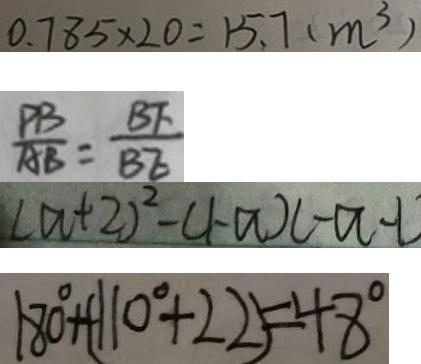Convert formula to latex. <formula><loc_0><loc_0><loc_500><loc_500>0 . 7 8 5 \times 2 0 = 1 5 . 7 ( m ^ { 3 } ) 
 \frac { P B } { A B } = \frac { B F } { B E } 
 ( a + 2 ) ^ { 2 } - ( 1 - a ) ( - a - 1 
 1 8 0 ^ { \circ } + ( 1 1 0 ^ { \circ } + 2 2 ) = 4 8 ^ { \circ }</formula> 